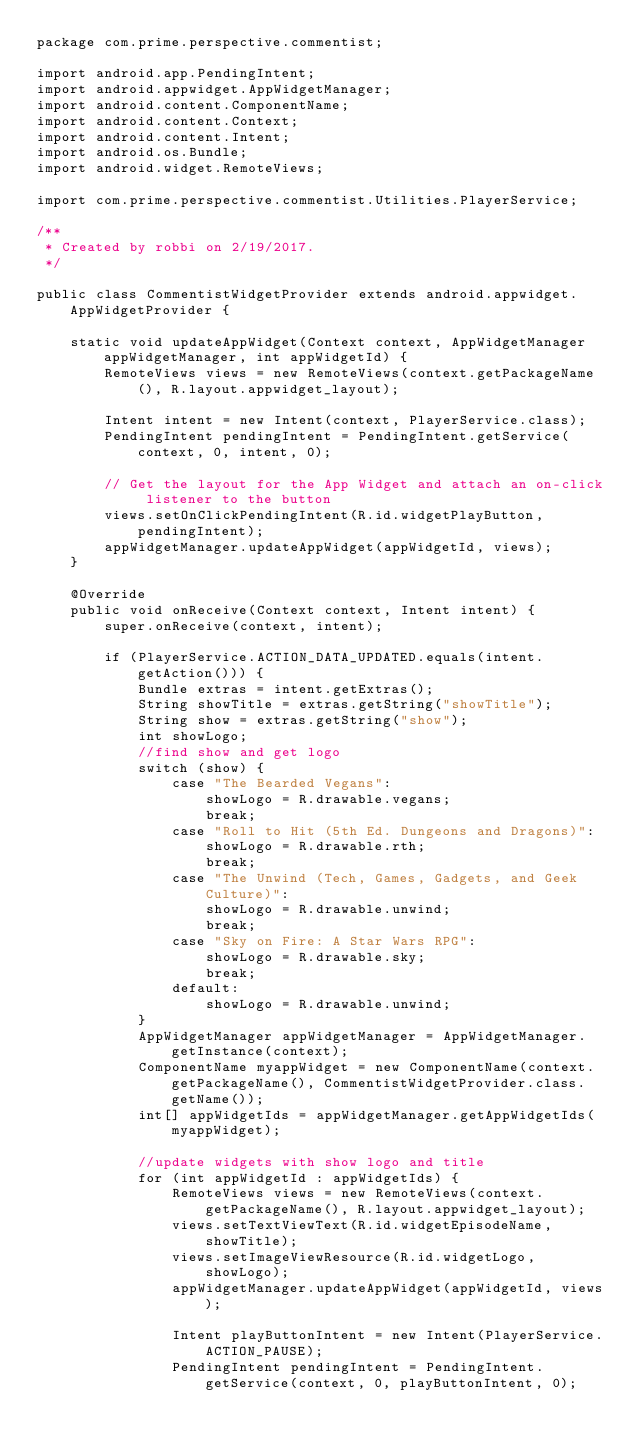<code> <loc_0><loc_0><loc_500><loc_500><_Java_>package com.prime.perspective.commentist;

import android.app.PendingIntent;
import android.appwidget.AppWidgetManager;
import android.content.ComponentName;
import android.content.Context;
import android.content.Intent;
import android.os.Bundle;
import android.widget.RemoteViews;

import com.prime.perspective.commentist.Utilities.PlayerService;

/**
 * Created by robbi on 2/19/2017.
 */

public class CommentistWidgetProvider extends android.appwidget.AppWidgetProvider {

    static void updateAppWidget(Context context, AppWidgetManager appWidgetManager, int appWidgetId) {
        RemoteViews views = new RemoteViews(context.getPackageName(), R.layout.appwidget_layout);

        Intent intent = new Intent(context, PlayerService.class);
        PendingIntent pendingIntent = PendingIntent.getService(context, 0, intent, 0);

        // Get the layout for the App Widget and attach an on-click listener to the button
        views.setOnClickPendingIntent(R.id.widgetPlayButton, pendingIntent);
        appWidgetManager.updateAppWidget(appWidgetId, views);
    }

    @Override
    public void onReceive(Context context, Intent intent) {
        super.onReceive(context, intent);

        if (PlayerService.ACTION_DATA_UPDATED.equals(intent.getAction())) {
            Bundle extras = intent.getExtras();
            String showTitle = extras.getString("showTitle");
            String show = extras.getString("show");
            int showLogo;
            //find show and get logo
            switch (show) {
                case "The Bearded Vegans":
                    showLogo = R.drawable.vegans;
                    break;
                case "Roll to Hit (5th Ed. Dungeons and Dragons)":
                    showLogo = R.drawable.rth;
                    break;
                case "The Unwind (Tech, Games, Gadgets, and Geek Culture)":
                    showLogo = R.drawable.unwind;
                    break;
                case "Sky on Fire: A Star Wars RPG":
                    showLogo = R.drawable.sky;
                    break;
                default:
                    showLogo = R.drawable.unwind;
            }
            AppWidgetManager appWidgetManager = AppWidgetManager.getInstance(context);
            ComponentName myappWidget = new ComponentName(context.getPackageName(), CommentistWidgetProvider.class.getName());
            int[] appWidgetIds = appWidgetManager.getAppWidgetIds(myappWidget);

            //update widgets with show logo and title
            for (int appWidgetId : appWidgetIds) {
                RemoteViews views = new RemoteViews(context.getPackageName(), R.layout.appwidget_layout);
                views.setTextViewText(R.id.widgetEpisodeName, showTitle);
                views.setImageViewResource(R.id.widgetLogo, showLogo);
                appWidgetManager.updateAppWidget(appWidgetId, views);

                Intent playButtonIntent = new Intent(PlayerService.ACTION_PAUSE);
                PendingIntent pendingIntent = PendingIntent.getService(context, 0, playButtonIntent, 0);</code> 